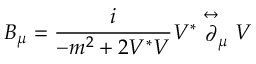Convert formula to latex. <formula><loc_0><loc_0><loc_500><loc_500>B _ { \mu } = \frac { i } { - m ^ { 2 } + 2 V ^ { * } V } V ^ { * } \stackrel { \leftrightarrow } { \partial } _ { \mu } V</formula> 